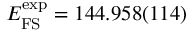<formula> <loc_0><loc_0><loc_500><loc_500>E _ { F S } ^ { e x p } = 1 4 4 . 9 5 8 ( 1 1 4 )</formula> 